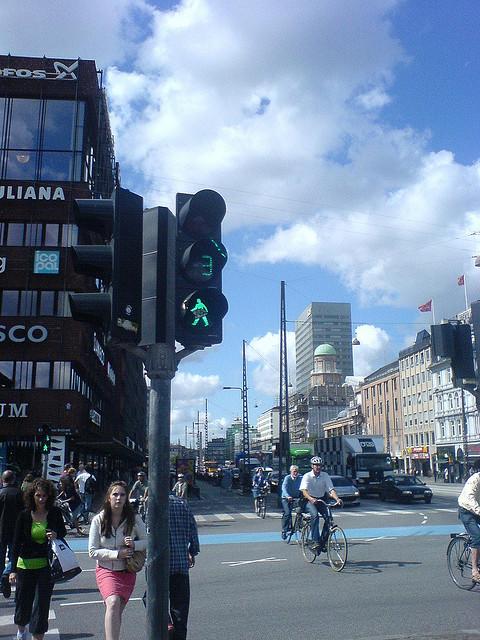How many seconds do the pedestrians have left on the green light?
Quick response, please. 3. Are the flags in the picture?
Write a very short answer. Yes. How many bikes are visible?
Keep it brief. 4. 